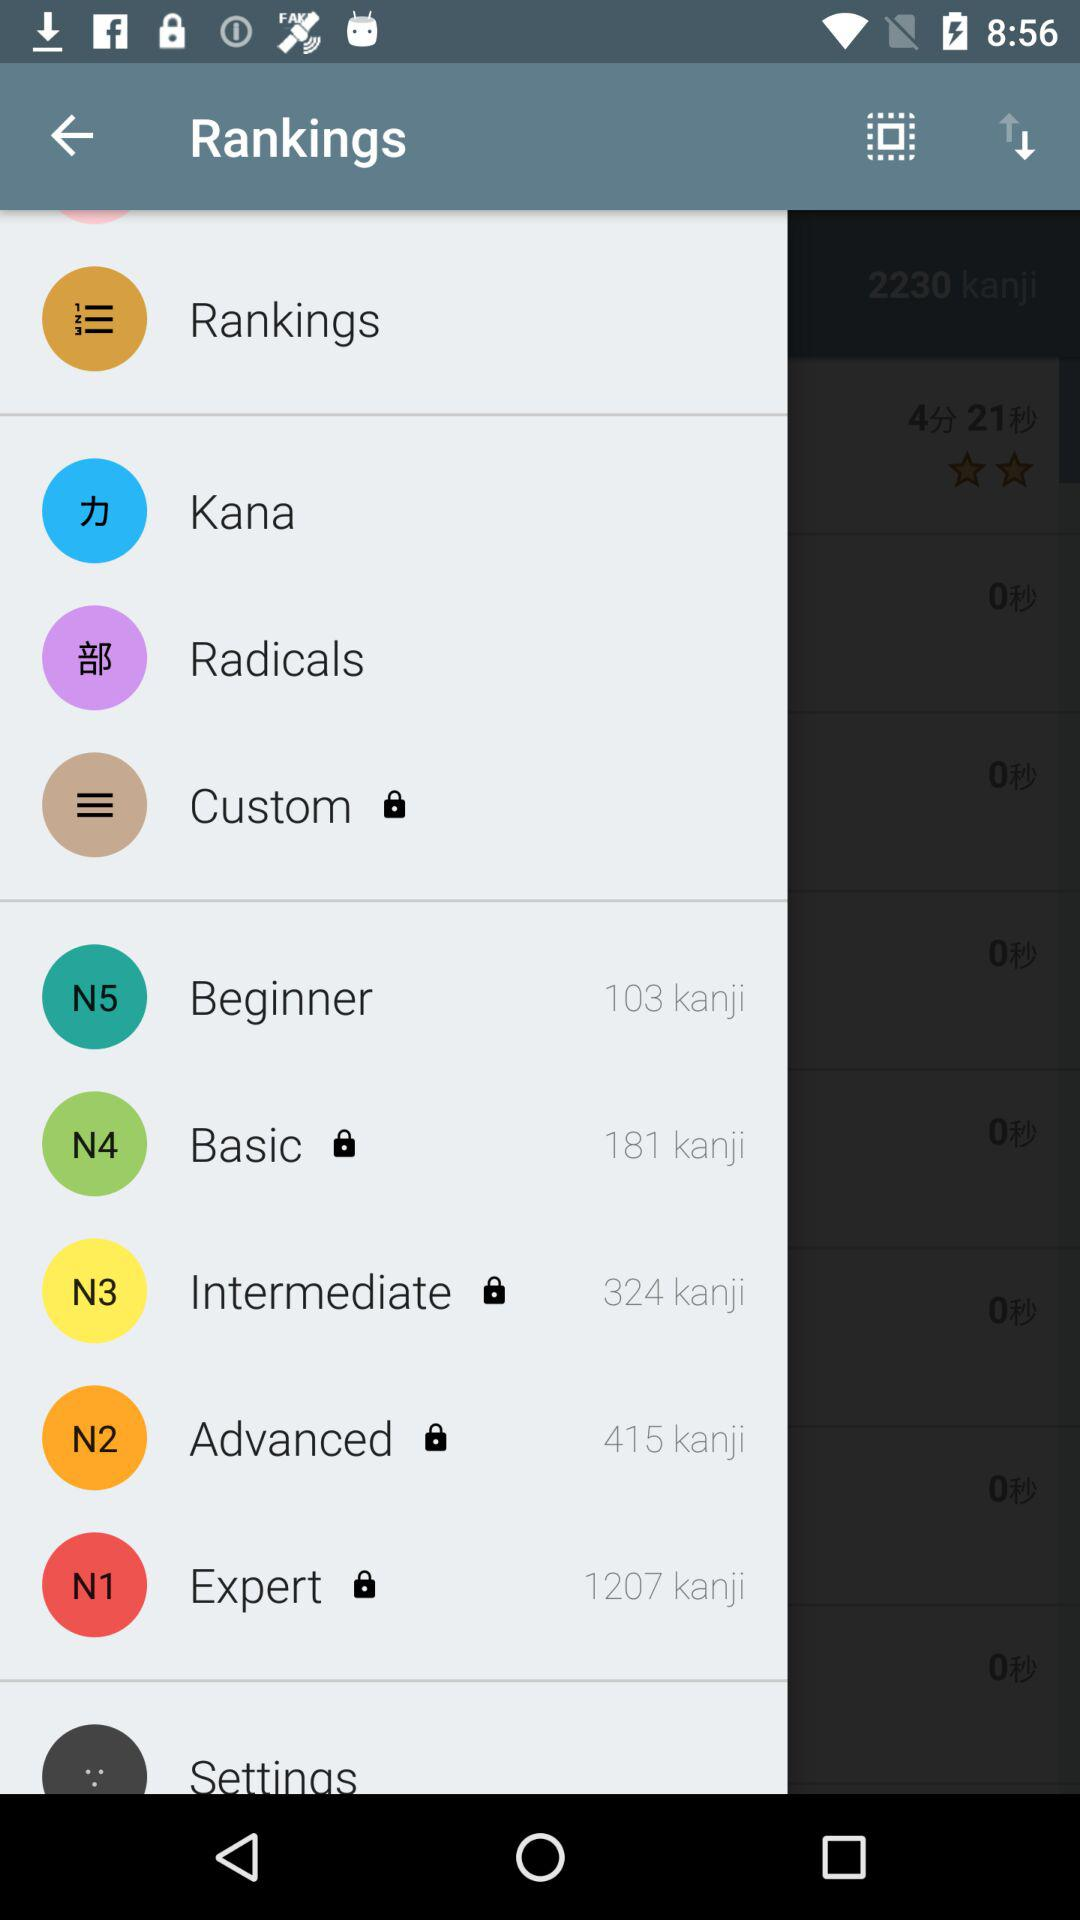How many more kanji are in the N1 level than the N5 level?
Answer the question using a single word or phrase. 1104 